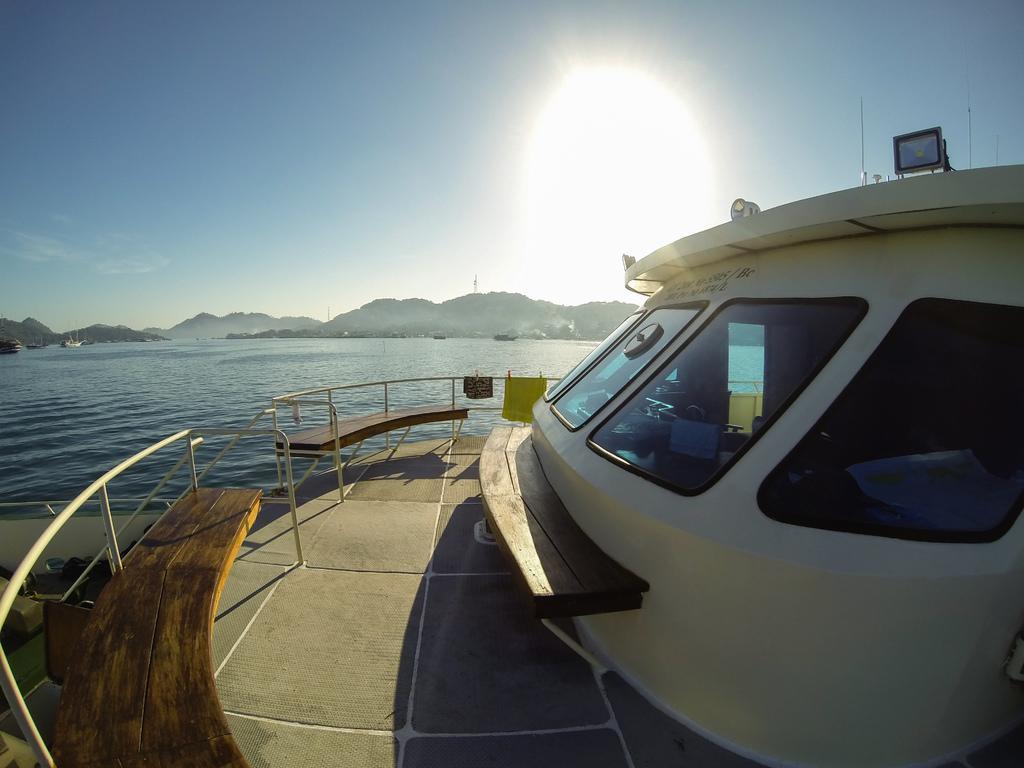Describe this image in one or two sentences. In this picture there is a boat on the water. At the back there are mountains and there are boats on the water. At the top there is sky and there is a sun and there are clouds. At the bottom there is water. 